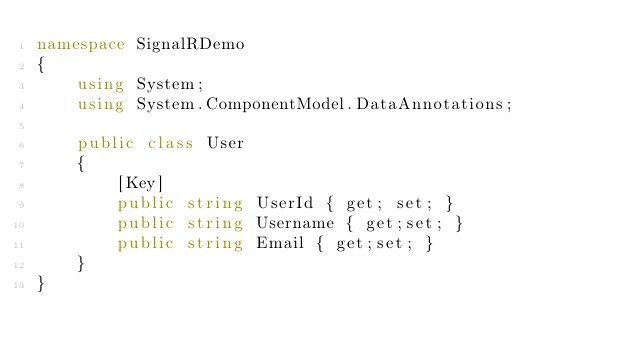<code> <loc_0><loc_0><loc_500><loc_500><_C#_>namespace SignalRDemo
{
    using System;
    using System.ComponentModel.DataAnnotations;

    public class User
    {
        [Key]
        public string UserId { get; set; }
        public string Username { get;set; }
        public string Email { get;set; }
    }
}</code> 